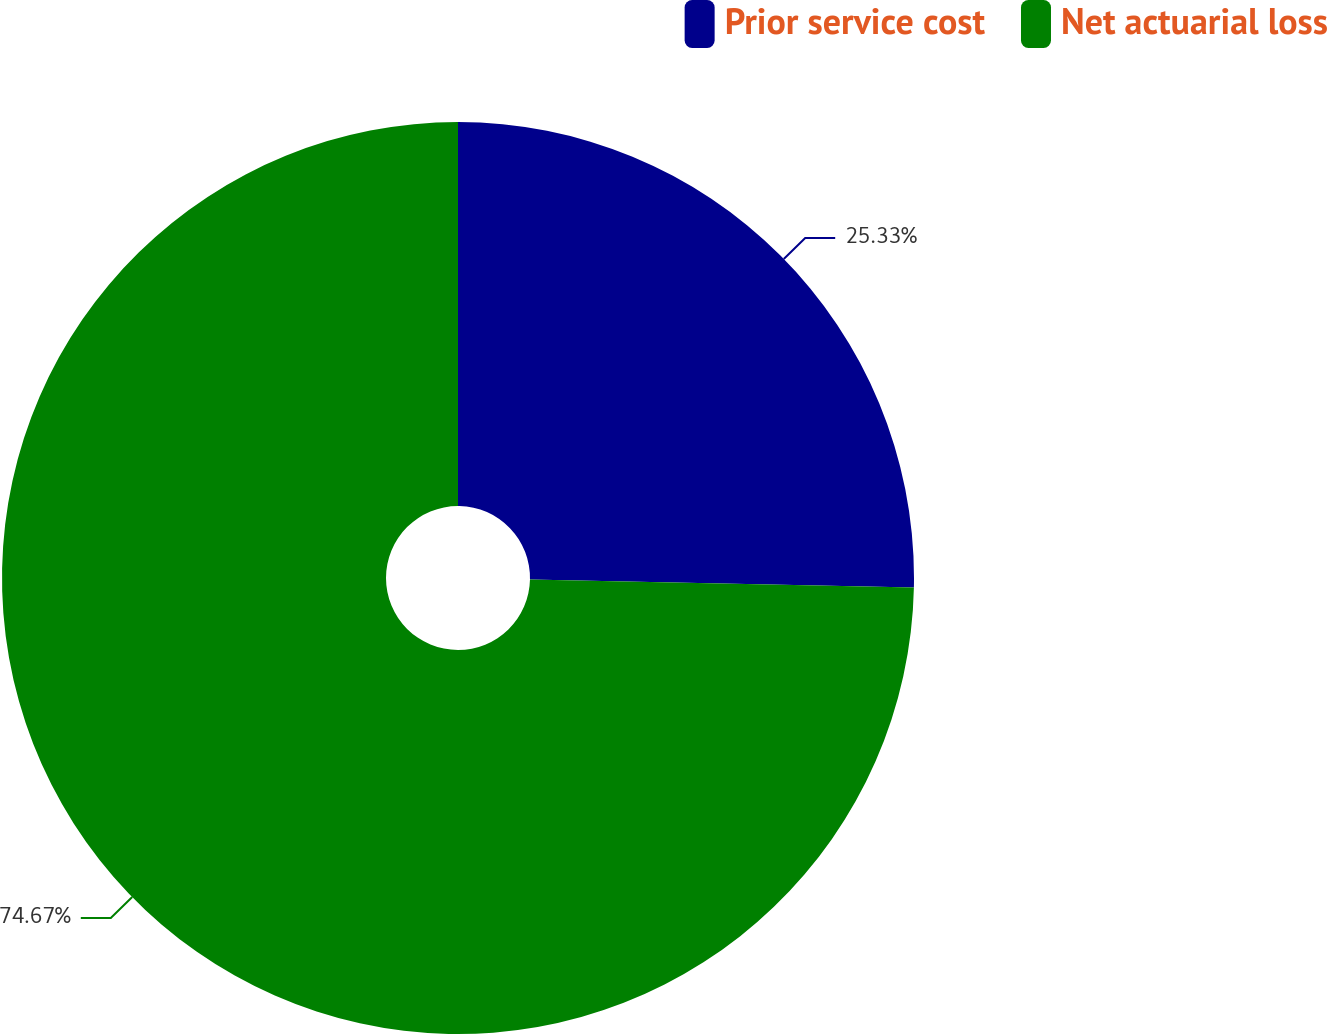Convert chart to OTSL. <chart><loc_0><loc_0><loc_500><loc_500><pie_chart><fcel>Prior service cost<fcel>Net actuarial loss<nl><fcel>25.33%<fcel>74.67%<nl></chart> 